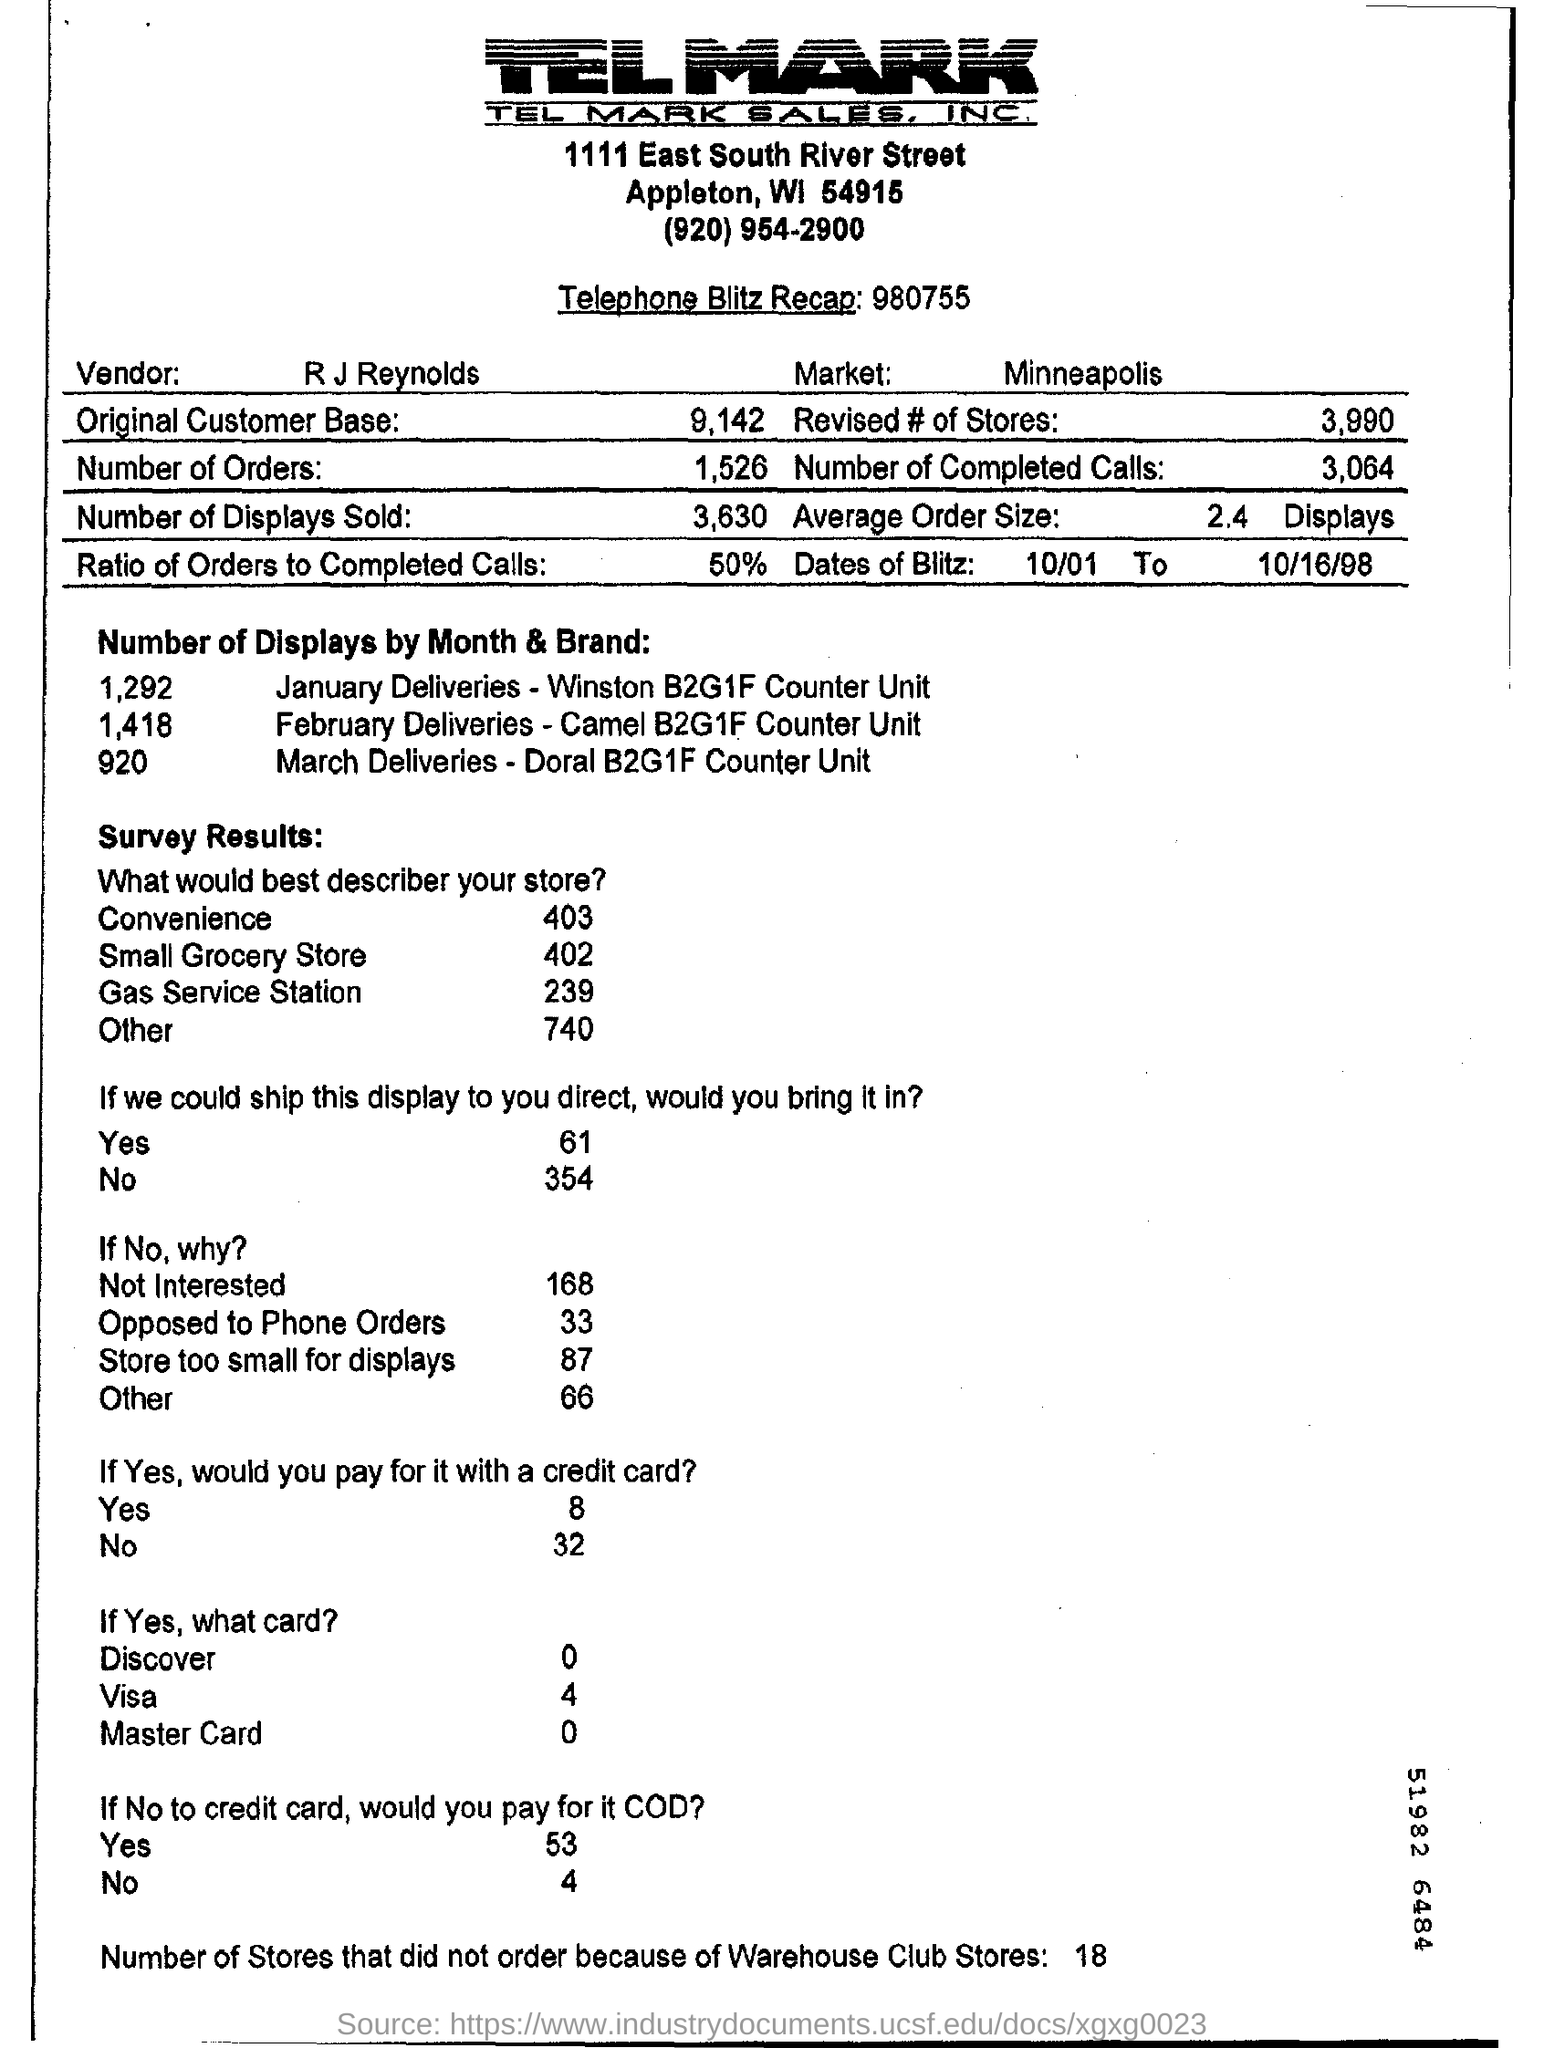Give some essential details in this illustration. The ratio of orders to completed calls is 50%. The average order size is 2.4. The telephone blitz recap was given, and the number provided was 980755... 